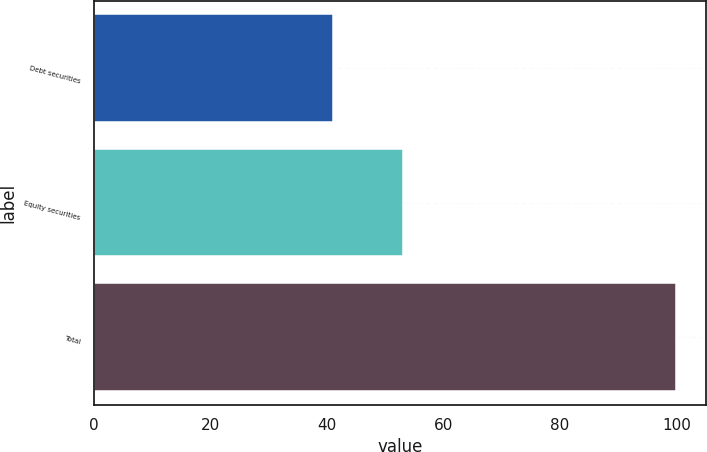Convert chart to OTSL. <chart><loc_0><loc_0><loc_500><loc_500><bar_chart><fcel>Debt securities<fcel>Equity securities<fcel>Total<nl><fcel>41<fcel>53<fcel>100<nl></chart> 